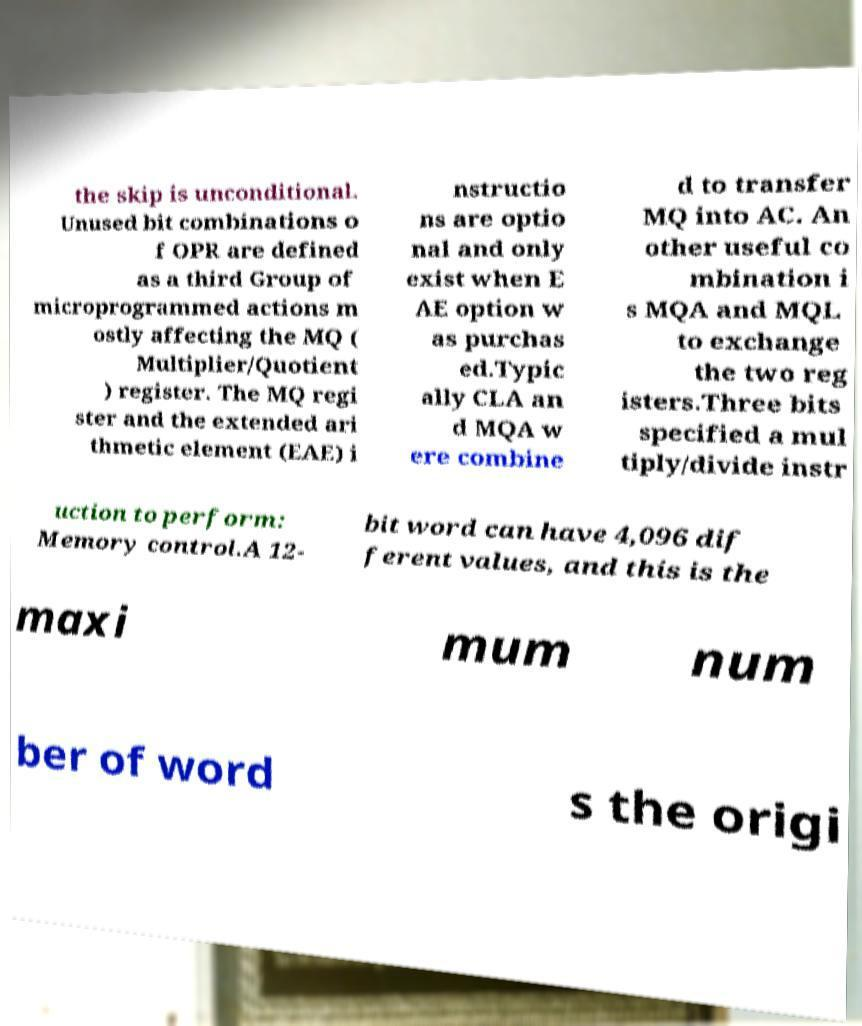Please identify and transcribe the text found in this image. the skip is unconditional. Unused bit combinations o f OPR are defined as a third Group of microprogrammed actions m ostly affecting the MQ ( Multiplier/Quotient ) register. The MQ regi ster and the extended ari thmetic element (EAE) i nstructio ns are optio nal and only exist when E AE option w as purchas ed.Typic ally CLA an d MQA w ere combine d to transfer MQ into AC. An other useful co mbination i s MQA and MQL to exchange the two reg isters.Three bits specified a mul tiply/divide instr uction to perform: Memory control.A 12- bit word can have 4,096 dif ferent values, and this is the maxi mum num ber of word s the origi 